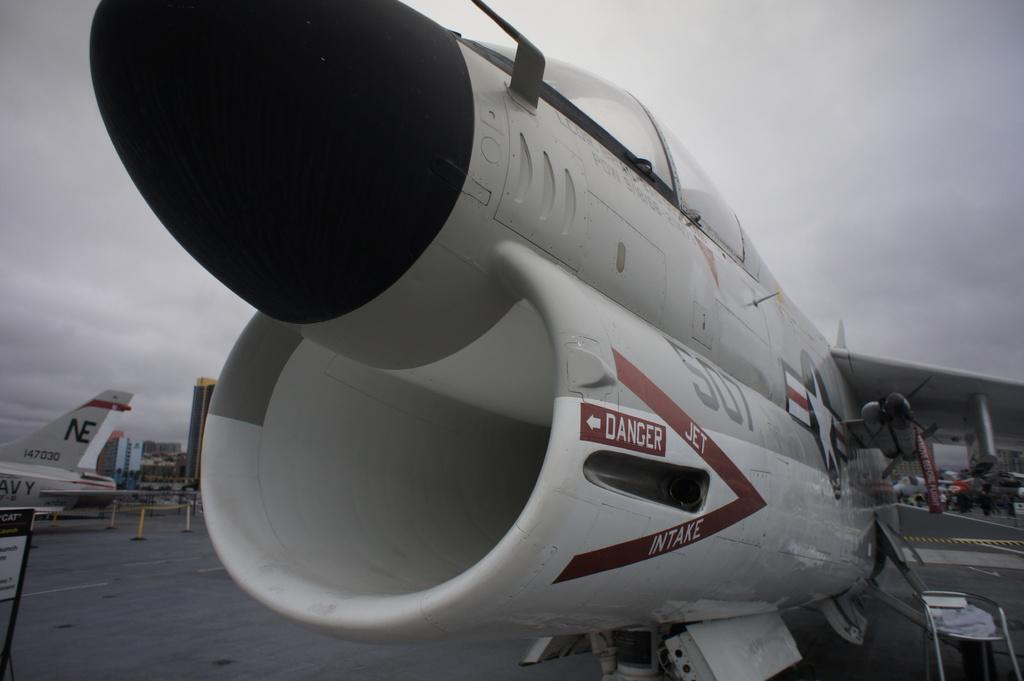<image>
Describe the image concisely. A jet engine with a danger warning on the side. 